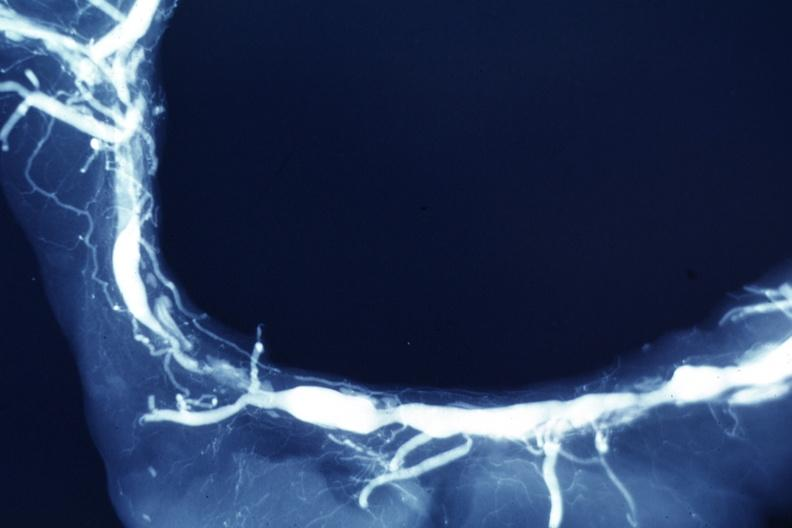where is this from?
Answer the question using a single word or phrase. Vasculature 